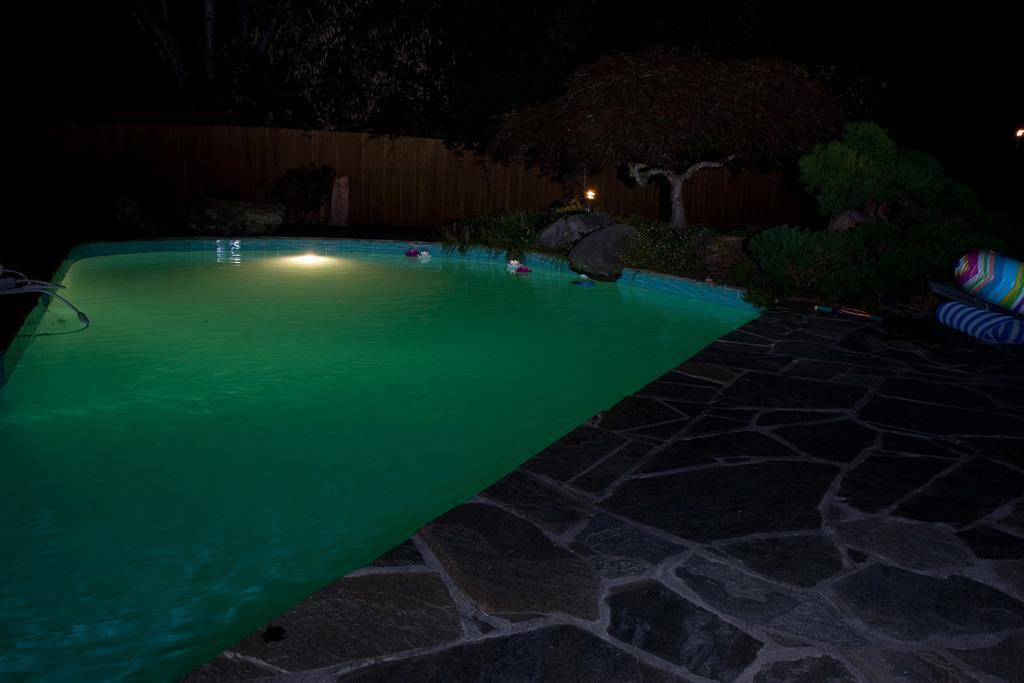Can you describe this image briefly? In this picture we can see a swimming pool, beside to the pool we can find few trees. 